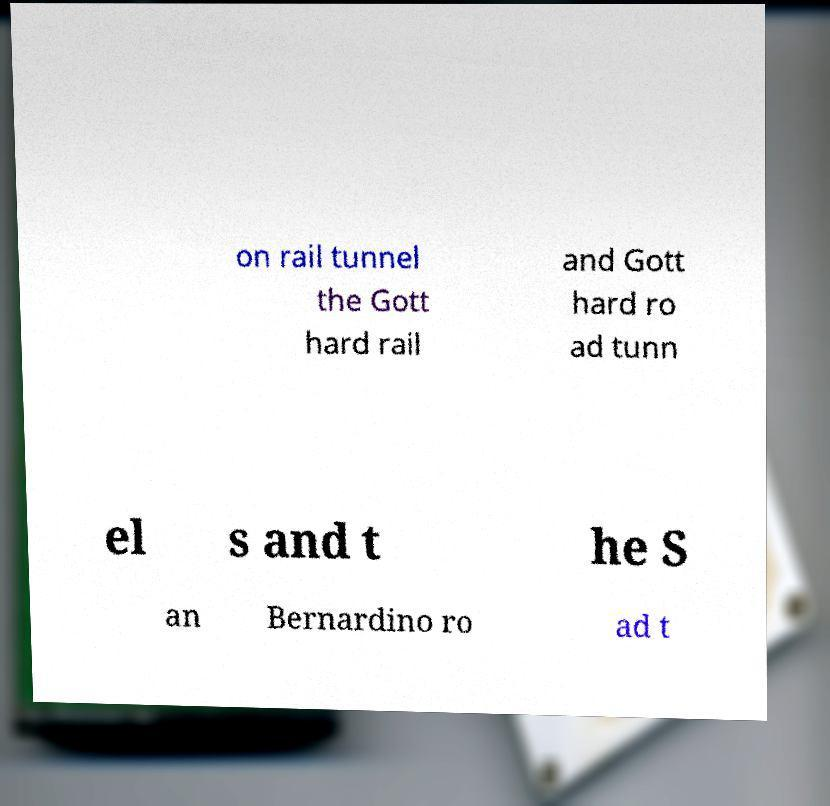Please identify and transcribe the text found in this image. on rail tunnel the Gott hard rail and Gott hard ro ad tunn el s and t he S an Bernardino ro ad t 